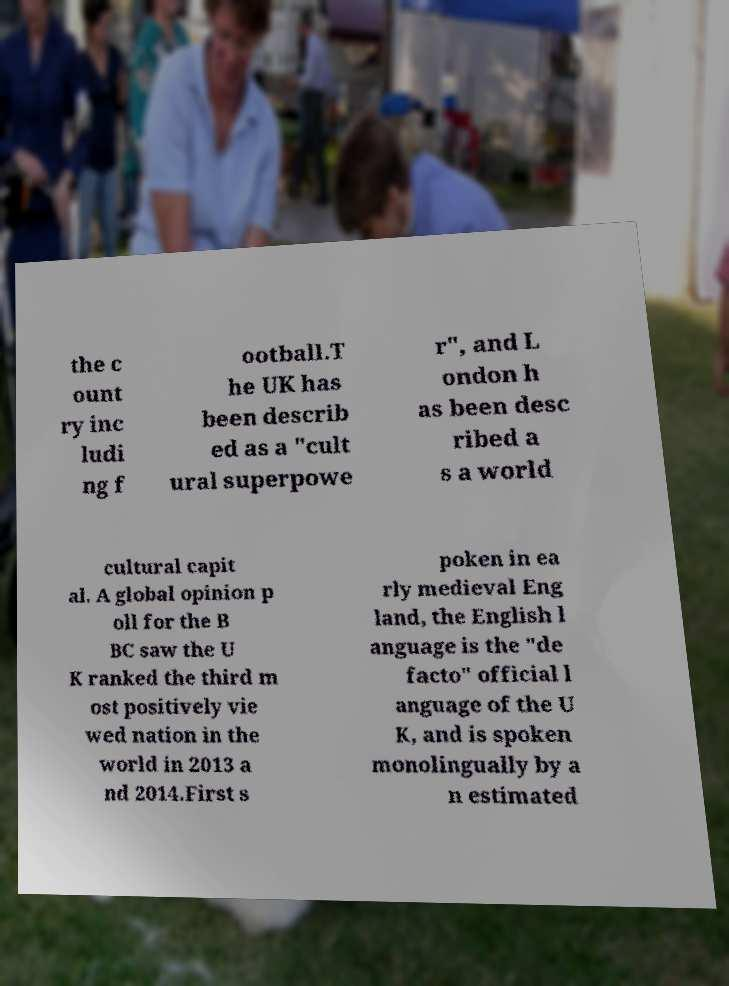Could you extract and type out the text from this image? the c ount ry inc ludi ng f ootball.T he UK has been describ ed as a "cult ural superpowe r", and L ondon h as been desc ribed a s a world cultural capit al. A global opinion p oll for the B BC saw the U K ranked the third m ost positively vie wed nation in the world in 2013 a nd 2014.First s poken in ea rly medieval Eng land, the English l anguage is the "de facto" official l anguage of the U K, and is spoken monolingually by a n estimated 